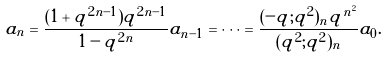Convert formula to latex. <formula><loc_0><loc_0><loc_500><loc_500>a _ { n } = \frac { ( 1 + q ^ { 2 n - 1 } ) q ^ { 2 n - 1 } } { 1 - q ^ { 2 n } } a _ { n - 1 } = \cdots = \frac { ( - q ; q ^ { 2 } ) _ { n } q ^ { n ^ { 2 } } } { ( q ^ { 2 } ; q ^ { 2 } ) _ { n } } a _ { 0 } .</formula> 